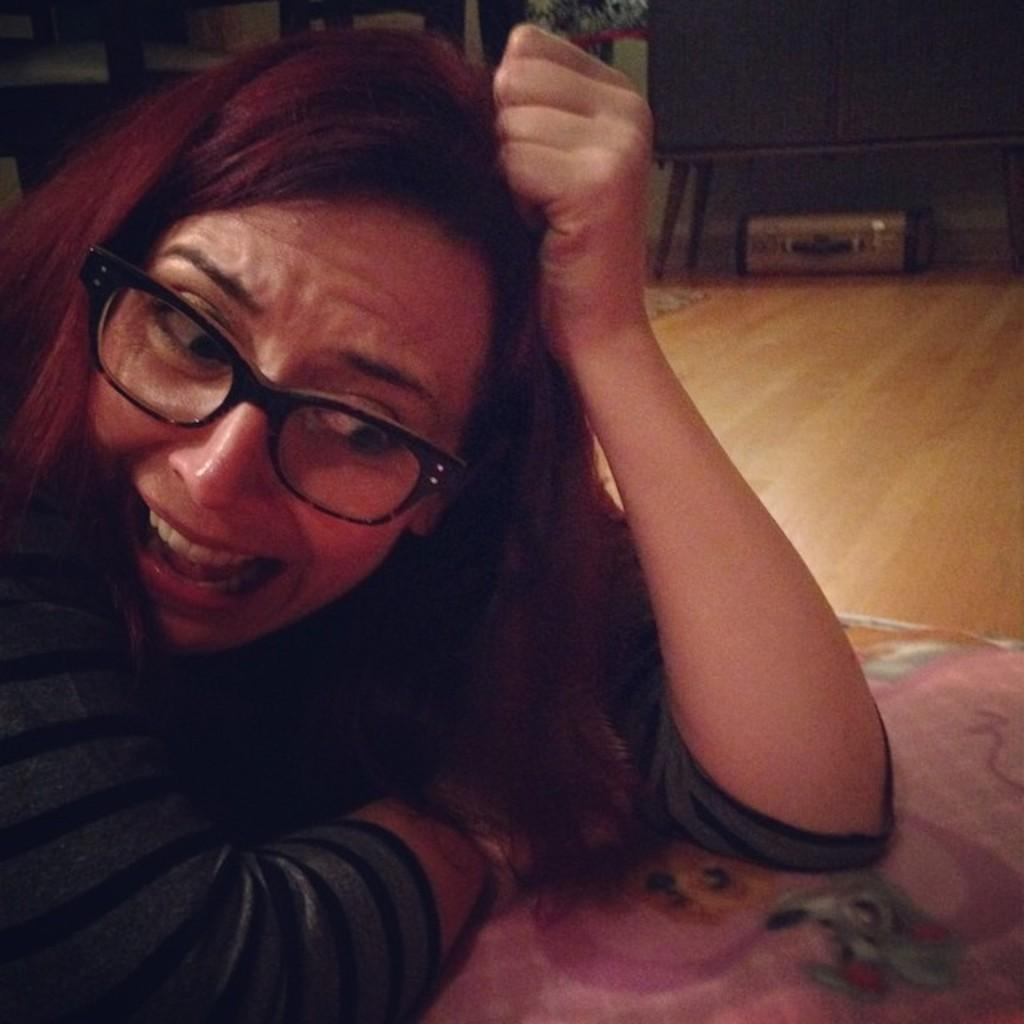Who is present in the image? There is a woman in the image. What accessory is the woman wearing? The woman is wearing spectacles. What can be seen in the background of the image? There is a floor and a suitcase visible in the background. Can you describe the brown-colored object above the suitcase? There is a brown-colored object above the suitcase, but its exact nature cannot be determined from the image. What type of rose is the woman holding in the image? There is no rose present in the image; the woman is not holding anything. How does the woman start her day in the image? The image does not provide any information about the woman's daily routine or how she starts her day. 